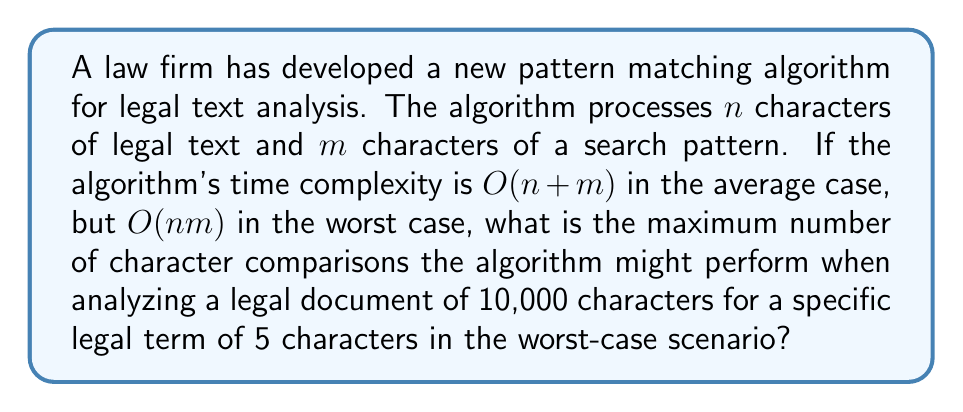Provide a solution to this math problem. To solve this problem, we need to follow these steps:

1. Identify the given information:
   - The length of the legal document (n) is 10,000 characters
   - The length of the search pattern (m) is 5 characters
   - The worst-case time complexity is $O(nm)$

2. Understand the meaning of worst-case time complexity:
   The $O(nm)$ notation indicates that in the worst case, the algorithm might need to perform up to a constant multiple of $nm$ operations.

3. Calculate the maximum number of comparisons:
   In the worst-case scenario, the algorithm might need to compare each character of the pattern with each character of the text. This results in:

   $$\text{Maximum comparisons} = n \times m$$

4. Substitute the given values:
   $$\text{Maximum comparisons} = 10,000 \times 5$$

5. Perform the calculation:
   $$\text{Maximum comparisons} = 50,000$$

Therefore, in the worst-case scenario, the algorithm might perform up to 50,000 character comparisons when analyzing the given legal document for the specific legal term.
Answer: 50,000 character comparisons 